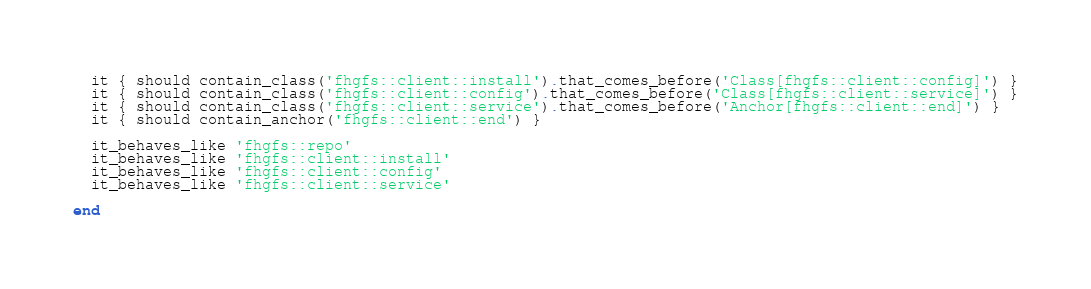<code> <loc_0><loc_0><loc_500><loc_500><_Ruby_>  it { should contain_class('fhgfs::client::install').that_comes_before('Class[fhgfs::client::config]') }
  it { should contain_class('fhgfs::client::config').that_comes_before('Class[fhgfs::client::service]') }
  it { should contain_class('fhgfs::client::service').that_comes_before('Anchor[fhgfs::client::end]') }
  it { should contain_anchor('fhgfs::client::end') }

  it_behaves_like 'fhgfs::repo'
  it_behaves_like 'fhgfs::client::install'
  it_behaves_like 'fhgfs::client::config'
  it_behaves_like 'fhgfs::client::service'

end
</code> 